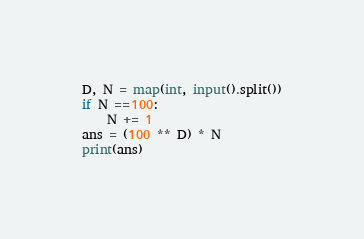<code> <loc_0><loc_0><loc_500><loc_500><_Python_>D, N = map(int, input().split())
if N ==100:
    N += 1
ans = (100 ** D) * N
print(ans)
</code> 